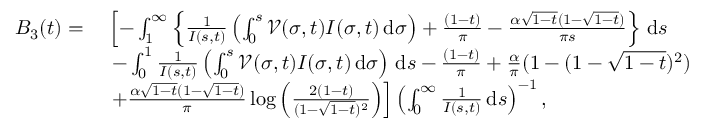Convert formula to latex. <formula><loc_0><loc_0><loc_500><loc_500>\begin{array} { r l } { B _ { 3 } ( t ) = } & { \, \left [ - \int _ { 1 } ^ { \infty } \left \{ \frac { 1 } { I ( s , t ) } \left ( \int _ { 0 } ^ { s } \mathcal { V } ( \sigma , t ) I ( \sigma , t ) \, d \sigma \right ) + \frac { ( 1 - t ) } { \pi } - \frac { \alpha \sqrt { 1 - t } ( 1 - \sqrt { 1 - t } ) } { \pi s } \right \} \, d s } \\ & { \, - \int _ { 0 } ^ { 1 } \frac { 1 } { I ( s , t ) } \left ( \int _ { 0 } ^ { s } \mathcal { V } ( \sigma , t ) I ( \sigma , t ) \, d \sigma \right ) \, d s - \frac { ( 1 - t ) } { \pi } + \frac { \alpha } { \pi } ( 1 - ( 1 - \sqrt { 1 - t } ) ^ { 2 } ) } \\ & { \, + \frac { \alpha \sqrt { 1 - t } ( 1 - \sqrt { 1 - t } ) } { \pi } \log \left ( \frac { 2 ( 1 - t ) } { ( 1 - \sqrt { 1 - t } ) ^ { 2 } } \right ) \right ] \left ( \int _ { 0 } ^ { \infty } \frac { 1 } { I ( s , t ) } \, d s \right ) ^ { - 1 } , } \end{array}</formula> 